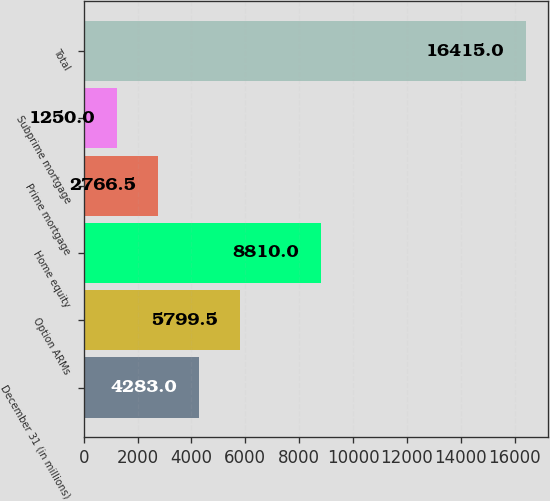<chart> <loc_0><loc_0><loc_500><loc_500><bar_chart><fcel>December 31 (in millions)<fcel>Option ARMs<fcel>Home equity<fcel>Prime mortgage<fcel>Subprime mortgage<fcel>Total<nl><fcel>4283<fcel>5799.5<fcel>8810<fcel>2766.5<fcel>1250<fcel>16415<nl></chart> 